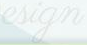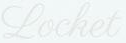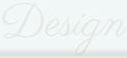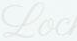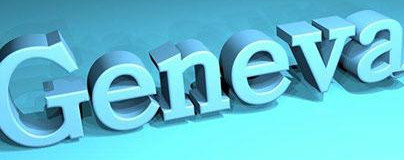What text is displayed in these images sequentially, separated by a semicolon? esign; Locket; Design; Loc; Geneva 